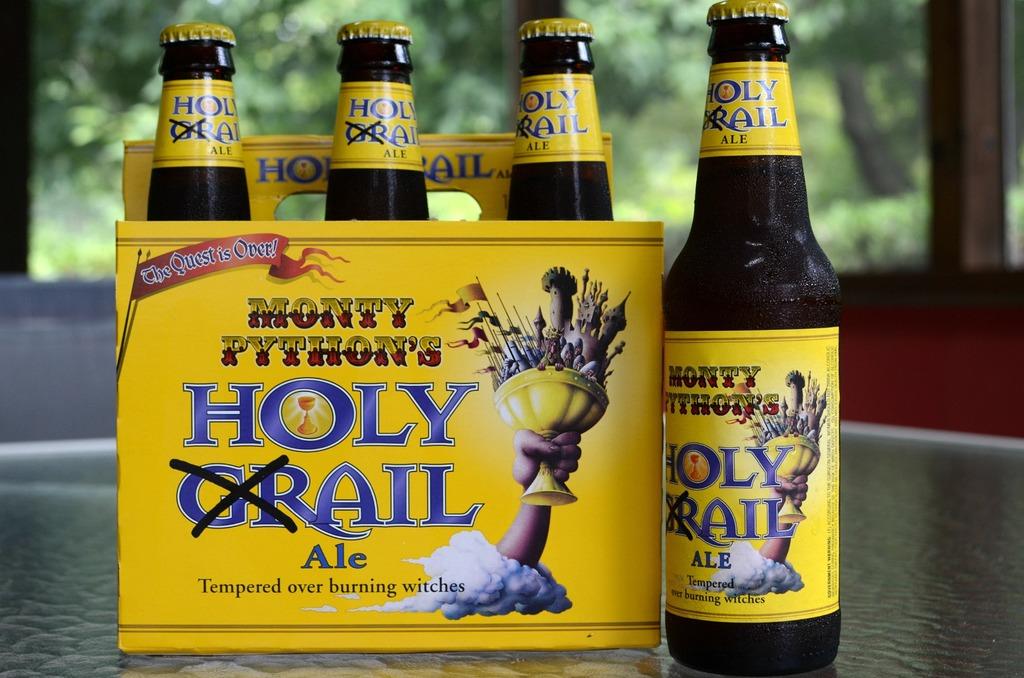What kind of ale is this?
Provide a succinct answer. Holy grail. How is this ale tempered?
Provide a short and direct response. Over burning witches. 